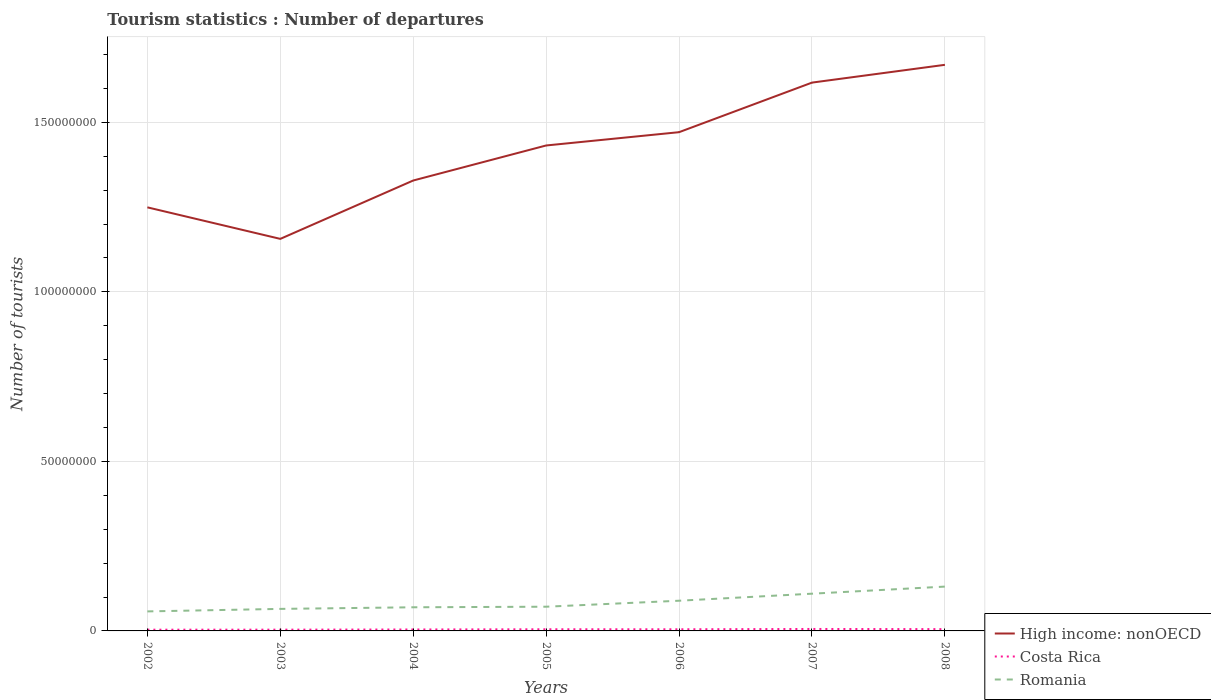How many different coloured lines are there?
Provide a short and direct response. 3. Is the number of lines equal to the number of legend labels?
Make the answer very short. Yes. Across all years, what is the maximum number of tourist departures in Romania?
Your answer should be very brief. 5.76e+06. In which year was the number of tourist departures in High income: nonOECD maximum?
Your answer should be very brief. 2003. What is the total number of tourist departures in Costa Rica in the graph?
Give a very brief answer. -1.52e+05. What is the difference between the highest and the second highest number of tourist departures in High income: nonOECD?
Give a very brief answer. 5.13e+07. What is the difference between the highest and the lowest number of tourist departures in Costa Rica?
Keep it short and to the point. 4. How many lines are there?
Your answer should be compact. 3. How many years are there in the graph?
Make the answer very short. 7. Does the graph contain any zero values?
Provide a succinct answer. No. Where does the legend appear in the graph?
Offer a terse response. Bottom right. How are the legend labels stacked?
Ensure brevity in your answer.  Vertical. What is the title of the graph?
Your response must be concise. Tourism statistics : Number of departures. What is the label or title of the Y-axis?
Your answer should be compact. Number of tourists. What is the Number of tourists of High income: nonOECD in 2002?
Your response must be concise. 1.25e+08. What is the Number of tourists of Costa Rica in 2002?
Give a very brief answer. 3.64e+05. What is the Number of tourists in Romania in 2002?
Make the answer very short. 5.76e+06. What is the Number of tourists of High income: nonOECD in 2003?
Provide a succinct answer. 1.16e+08. What is the Number of tourists in Costa Rica in 2003?
Your response must be concise. 3.73e+05. What is the Number of tourists in Romania in 2003?
Provide a short and direct response. 6.50e+06. What is the Number of tourists of High income: nonOECD in 2004?
Ensure brevity in your answer.  1.33e+08. What is the Number of tourists of Costa Rica in 2004?
Offer a terse response. 4.25e+05. What is the Number of tourists of Romania in 2004?
Provide a short and direct response. 6.97e+06. What is the Number of tourists in High income: nonOECD in 2005?
Make the answer very short. 1.43e+08. What is the Number of tourists in Costa Rica in 2005?
Offer a very short reply. 4.87e+05. What is the Number of tourists of Romania in 2005?
Offer a very short reply. 7.14e+06. What is the Number of tourists of High income: nonOECD in 2006?
Provide a succinct answer. 1.47e+08. What is the Number of tourists in Costa Rica in 2006?
Give a very brief answer. 4.85e+05. What is the Number of tourists of Romania in 2006?
Your answer should be compact. 8.91e+06. What is the Number of tourists of High income: nonOECD in 2007?
Provide a short and direct response. 1.62e+08. What is the Number of tourists in Costa Rica in 2007?
Make the answer very short. 5.77e+05. What is the Number of tourists of Romania in 2007?
Your answer should be compact. 1.10e+07. What is the Number of tourists of High income: nonOECD in 2008?
Offer a terse response. 1.67e+08. What is the Number of tourists in Costa Rica in 2008?
Your answer should be compact. 5.28e+05. What is the Number of tourists of Romania in 2008?
Ensure brevity in your answer.  1.31e+07. Across all years, what is the maximum Number of tourists of High income: nonOECD?
Your answer should be compact. 1.67e+08. Across all years, what is the maximum Number of tourists in Costa Rica?
Your answer should be compact. 5.77e+05. Across all years, what is the maximum Number of tourists in Romania?
Give a very brief answer. 1.31e+07. Across all years, what is the minimum Number of tourists of High income: nonOECD?
Provide a succinct answer. 1.16e+08. Across all years, what is the minimum Number of tourists in Costa Rica?
Ensure brevity in your answer.  3.64e+05. Across all years, what is the minimum Number of tourists of Romania?
Provide a short and direct response. 5.76e+06. What is the total Number of tourists of High income: nonOECD in the graph?
Give a very brief answer. 9.92e+08. What is the total Number of tourists of Costa Rica in the graph?
Your response must be concise. 3.24e+06. What is the total Number of tourists in Romania in the graph?
Your response must be concise. 5.93e+07. What is the difference between the Number of tourists in High income: nonOECD in 2002 and that in 2003?
Ensure brevity in your answer.  9.30e+06. What is the difference between the Number of tourists of Costa Rica in 2002 and that in 2003?
Keep it short and to the point. -9000. What is the difference between the Number of tourists in Romania in 2002 and that in 2003?
Provide a short and direct response. -7.40e+05. What is the difference between the Number of tourists of High income: nonOECD in 2002 and that in 2004?
Your answer should be compact. -7.91e+06. What is the difference between the Number of tourists in Costa Rica in 2002 and that in 2004?
Give a very brief answer. -6.10e+04. What is the difference between the Number of tourists in Romania in 2002 and that in 2004?
Your response must be concise. -1.22e+06. What is the difference between the Number of tourists in High income: nonOECD in 2002 and that in 2005?
Provide a succinct answer. -1.82e+07. What is the difference between the Number of tourists of Costa Rica in 2002 and that in 2005?
Provide a succinct answer. -1.23e+05. What is the difference between the Number of tourists of Romania in 2002 and that in 2005?
Your answer should be very brief. -1.38e+06. What is the difference between the Number of tourists of High income: nonOECD in 2002 and that in 2006?
Give a very brief answer. -2.22e+07. What is the difference between the Number of tourists of Costa Rica in 2002 and that in 2006?
Offer a very short reply. -1.21e+05. What is the difference between the Number of tourists in Romania in 2002 and that in 2006?
Provide a short and direct response. -3.15e+06. What is the difference between the Number of tourists of High income: nonOECD in 2002 and that in 2007?
Provide a short and direct response. -3.68e+07. What is the difference between the Number of tourists of Costa Rica in 2002 and that in 2007?
Your answer should be very brief. -2.13e+05. What is the difference between the Number of tourists of Romania in 2002 and that in 2007?
Offer a terse response. -5.22e+06. What is the difference between the Number of tourists in High income: nonOECD in 2002 and that in 2008?
Keep it short and to the point. -4.20e+07. What is the difference between the Number of tourists in Costa Rica in 2002 and that in 2008?
Provide a short and direct response. -1.64e+05. What is the difference between the Number of tourists in Romania in 2002 and that in 2008?
Offer a terse response. -7.32e+06. What is the difference between the Number of tourists of High income: nonOECD in 2003 and that in 2004?
Your response must be concise. -1.72e+07. What is the difference between the Number of tourists in Costa Rica in 2003 and that in 2004?
Offer a very short reply. -5.20e+04. What is the difference between the Number of tourists of Romania in 2003 and that in 2004?
Your answer should be compact. -4.75e+05. What is the difference between the Number of tourists of High income: nonOECD in 2003 and that in 2005?
Make the answer very short. -2.75e+07. What is the difference between the Number of tourists of Costa Rica in 2003 and that in 2005?
Make the answer very short. -1.14e+05. What is the difference between the Number of tourists of Romania in 2003 and that in 2005?
Give a very brief answer. -6.43e+05. What is the difference between the Number of tourists of High income: nonOECD in 2003 and that in 2006?
Your answer should be compact. -3.15e+07. What is the difference between the Number of tourists of Costa Rica in 2003 and that in 2006?
Give a very brief answer. -1.12e+05. What is the difference between the Number of tourists of Romania in 2003 and that in 2006?
Your response must be concise. -2.41e+06. What is the difference between the Number of tourists in High income: nonOECD in 2003 and that in 2007?
Ensure brevity in your answer.  -4.61e+07. What is the difference between the Number of tourists of Costa Rica in 2003 and that in 2007?
Make the answer very short. -2.04e+05. What is the difference between the Number of tourists of Romania in 2003 and that in 2007?
Offer a terse response. -4.48e+06. What is the difference between the Number of tourists in High income: nonOECD in 2003 and that in 2008?
Your response must be concise. -5.13e+07. What is the difference between the Number of tourists in Costa Rica in 2003 and that in 2008?
Ensure brevity in your answer.  -1.55e+05. What is the difference between the Number of tourists in Romania in 2003 and that in 2008?
Provide a succinct answer. -6.58e+06. What is the difference between the Number of tourists in High income: nonOECD in 2004 and that in 2005?
Ensure brevity in your answer.  -1.03e+07. What is the difference between the Number of tourists in Costa Rica in 2004 and that in 2005?
Provide a short and direct response. -6.20e+04. What is the difference between the Number of tourists of Romania in 2004 and that in 2005?
Ensure brevity in your answer.  -1.68e+05. What is the difference between the Number of tourists of High income: nonOECD in 2004 and that in 2006?
Offer a very short reply. -1.43e+07. What is the difference between the Number of tourists of Romania in 2004 and that in 2006?
Ensure brevity in your answer.  -1.93e+06. What is the difference between the Number of tourists of High income: nonOECD in 2004 and that in 2007?
Make the answer very short. -2.89e+07. What is the difference between the Number of tourists of Costa Rica in 2004 and that in 2007?
Provide a succinct answer. -1.52e+05. What is the difference between the Number of tourists in Romania in 2004 and that in 2007?
Give a very brief answer. -4.01e+06. What is the difference between the Number of tourists in High income: nonOECD in 2004 and that in 2008?
Ensure brevity in your answer.  -3.41e+07. What is the difference between the Number of tourists in Costa Rica in 2004 and that in 2008?
Your response must be concise. -1.03e+05. What is the difference between the Number of tourists in Romania in 2004 and that in 2008?
Provide a short and direct response. -6.10e+06. What is the difference between the Number of tourists in High income: nonOECD in 2005 and that in 2006?
Keep it short and to the point. -3.92e+06. What is the difference between the Number of tourists of Costa Rica in 2005 and that in 2006?
Offer a terse response. 2000. What is the difference between the Number of tourists in Romania in 2005 and that in 2006?
Keep it short and to the point. -1.77e+06. What is the difference between the Number of tourists of High income: nonOECD in 2005 and that in 2007?
Your response must be concise. -1.85e+07. What is the difference between the Number of tourists of Costa Rica in 2005 and that in 2007?
Your answer should be very brief. -9.00e+04. What is the difference between the Number of tourists in Romania in 2005 and that in 2007?
Your answer should be compact. -3.84e+06. What is the difference between the Number of tourists of High income: nonOECD in 2005 and that in 2008?
Make the answer very short. -2.38e+07. What is the difference between the Number of tourists of Costa Rica in 2005 and that in 2008?
Your answer should be compact. -4.10e+04. What is the difference between the Number of tourists of Romania in 2005 and that in 2008?
Make the answer very short. -5.93e+06. What is the difference between the Number of tourists in High income: nonOECD in 2006 and that in 2007?
Ensure brevity in your answer.  -1.46e+07. What is the difference between the Number of tourists of Costa Rica in 2006 and that in 2007?
Offer a terse response. -9.20e+04. What is the difference between the Number of tourists in Romania in 2006 and that in 2007?
Ensure brevity in your answer.  -2.07e+06. What is the difference between the Number of tourists of High income: nonOECD in 2006 and that in 2008?
Your answer should be compact. -1.99e+07. What is the difference between the Number of tourists of Costa Rica in 2006 and that in 2008?
Your answer should be compact. -4.30e+04. What is the difference between the Number of tourists of Romania in 2006 and that in 2008?
Offer a very short reply. -4.17e+06. What is the difference between the Number of tourists of High income: nonOECD in 2007 and that in 2008?
Your answer should be compact. -5.25e+06. What is the difference between the Number of tourists in Costa Rica in 2007 and that in 2008?
Give a very brief answer. 4.90e+04. What is the difference between the Number of tourists of Romania in 2007 and that in 2008?
Your response must be concise. -2.09e+06. What is the difference between the Number of tourists in High income: nonOECD in 2002 and the Number of tourists in Costa Rica in 2003?
Your answer should be compact. 1.25e+08. What is the difference between the Number of tourists of High income: nonOECD in 2002 and the Number of tourists of Romania in 2003?
Your answer should be compact. 1.18e+08. What is the difference between the Number of tourists of Costa Rica in 2002 and the Number of tourists of Romania in 2003?
Make the answer very short. -6.13e+06. What is the difference between the Number of tourists in High income: nonOECD in 2002 and the Number of tourists in Costa Rica in 2004?
Your response must be concise. 1.24e+08. What is the difference between the Number of tourists in High income: nonOECD in 2002 and the Number of tourists in Romania in 2004?
Give a very brief answer. 1.18e+08. What is the difference between the Number of tourists in Costa Rica in 2002 and the Number of tourists in Romania in 2004?
Your answer should be compact. -6.61e+06. What is the difference between the Number of tourists in High income: nonOECD in 2002 and the Number of tourists in Costa Rica in 2005?
Your response must be concise. 1.24e+08. What is the difference between the Number of tourists of High income: nonOECD in 2002 and the Number of tourists of Romania in 2005?
Make the answer very short. 1.18e+08. What is the difference between the Number of tourists of Costa Rica in 2002 and the Number of tourists of Romania in 2005?
Provide a succinct answer. -6.78e+06. What is the difference between the Number of tourists of High income: nonOECD in 2002 and the Number of tourists of Costa Rica in 2006?
Offer a terse response. 1.24e+08. What is the difference between the Number of tourists of High income: nonOECD in 2002 and the Number of tourists of Romania in 2006?
Make the answer very short. 1.16e+08. What is the difference between the Number of tourists of Costa Rica in 2002 and the Number of tourists of Romania in 2006?
Your response must be concise. -8.54e+06. What is the difference between the Number of tourists of High income: nonOECD in 2002 and the Number of tourists of Costa Rica in 2007?
Offer a very short reply. 1.24e+08. What is the difference between the Number of tourists of High income: nonOECD in 2002 and the Number of tourists of Romania in 2007?
Offer a terse response. 1.14e+08. What is the difference between the Number of tourists in Costa Rica in 2002 and the Number of tourists in Romania in 2007?
Offer a terse response. -1.06e+07. What is the difference between the Number of tourists of High income: nonOECD in 2002 and the Number of tourists of Costa Rica in 2008?
Provide a short and direct response. 1.24e+08. What is the difference between the Number of tourists in High income: nonOECD in 2002 and the Number of tourists in Romania in 2008?
Offer a very short reply. 1.12e+08. What is the difference between the Number of tourists of Costa Rica in 2002 and the Number of tourists of Romania in 2008?
Provide a succinct answer. -1.27e+07. What is the difference between the Number of tourists of High income: nonOECD in 2003 and the Number of tourists of Costa Rica in 2004?
Offer a very short reply. 1.15e+08. What is the difference between the Number of tourists of High income: nonOECD in 2003 and the Number of tourists of Romania in 2004?
Ensure brevity in your answer.  1.09e+08. What is the difference between the Number of tourists in Costa Rica in 2003 and the Number of tourists in Romania in 2004?
Provide a succinct answer. -6.60e+06. What is the difference between the Number of tourists in High income: nonOECD in 2003 and the Number of tourists in Costa Rica in 2005?
Offer a very short reply. 1.15e+08. What is the difference between the Number of tourists of High income: nonOECD in 2003 and the Number of tourists of Romania in 2005?
Provide a succinct answer. 1.08e+08. What is the difference between the Number of tourists of Costa Rica in 2003 and the Number of tourists of Romania in 2005?
Offer a very short reply. -6.77e+06. What is the difference between the Number of tourists in High income: nonOECD in 2003 and the Number of tourists in Costa Rica in 2006?
Provide a short and direct response. 1.15e+08. What is the difference between the Number of tourists in High income: nonOECD in 2003 and the Number of tourists in Romania in 2006?
Keep it short and to the point. 1.07e+08. What is the difference between the Number of tourists of Costa Rica in 2003 and the Number of tourists of Romania in 2006?
Make the answer very short. -8.53e+06. What is the difference between the Number of tourists in High income: nonOECD in 2003 and the Number of tourists in Costa Rica in 2007?
Give a very brief answer. 1.15e+08. What is the difference between the Number of tourists of High income: nonOECD in 2003 and the Number of tourists of Romania in 2007?
Your answer should be compact. 1.05e+08. What is the difference between the Number of tourists of Costa Rica in 2003 and the Number of tourists of Romania in 2007?
Your answer should be compact. -1.06e+07. What is the difference between the Number of tourists of High income: nonOECD in 2003 and the Number of tourists of Costa Rica in 2008?
Provide a short and direct response. 1.15e+08. What is the difference between the Number of tourists of High income: nonOECD in 2003 and the Number of tourists of Romania in 2008?
Your answer should be very brief. 1.03e+08. What is the difference between the Number of tourists of Costa Rica in 2003 and the Number of tourists of Romania in 2008?
Give a very brief answer. -1.27e+07. What is the difference between the Number of tourists of High income: nonOECD in 2004 and the Number of tourists of Costa Rica in 2005?
Your response must be concise. 1.32e+08. What is the difference between the Number of tourists of High income: nonOECD in 2004 and the Number of tourists of Romania in 2005?
Give a very brief answer. 1.26e+08. What is the difference between the Number of tourists of Costa Rica in 2004 and the Number of tourists of Romania in 2005?
Give a very brief answer. -6.72e+06. What is the difference between the Number of tourists in High income: nonOECD in 2004 and the Number of tourists in Costa Rica in 2006?
Give a very brief answer. 1.32e+08. What is the difference between the Number of tourists in High income: nonOECD in 2004 and the Number of tourists in Romania in 2006?
Your answer should be very brief. 1.24e+08. What is the difference between the Number of tourists of Costa Rica in 2004 and the Number of tourists of Romania in 2006?
Offer a very short reply. -8.48e+06. What is the difference between the Number of tourists in High income: nonOECD in 2004 and the Number of tourists in Costa Rica in 2007?
Ensure brevity in your answer.  1.32e+08. What is the difference between the Number of tourists of High income: nonOECD in 2004 and the Number of tourists of Romania in 2007?
Ensure brevity in your answer.  1.22e+08. What is the difference between the Number of tourists in Costa Rica in 2004 and the Number of tourists in Romania in 2007?
Make the answer very short. -1.06e+07. What is the difference between the Number of tourists of High income: nonOECD in 2004 and the Number of tourists of Costa Rica in 2008?
Your response must be concise. 1.32e+08. What is the difference between the Number of tourists of High income: nonOECD in 2004 and the Number of tourists of Romania in 2008?
Offer a very short reply. 1.20e+08. What is the difference between the Number of tourists in Costa Rica in 2004 and the Number of tourists in Romania in 2008?
Provide a short and direct response. -1.26e+07. What is the difference between the Number of tourists in High income: nonOECD in 2005 and the Number of tourists in Costa Rica in 2006?
Ensure brevity in your answer.  1.43e+08. What is the difference between the Number of tourists of High income: nonOECD in 2005 and the Number of tourists of Romania in 2006?
Give a very brief answer. 1.34e+08. What is the difference between the Number of tourists in Costa Rica in 2005 and the Number of tourists in Romania in 2006?
Offer a terse response. -8.42e+06. What is the difference between the Number of tourists of High income: nonOECD in 2005 and the Number of tourists of Costa Rica in 2007?
Your answer should be compact. 1.43e+08. What is the difference between the Number of tourists in High income: nonOECD in 2005 and the Number of tourists in Romania in 2007?
Give a very brief answer. 1.32e+08. What is the difference between the Number of tourists of Costa Rica in 2005 and the Number of tourists of Romania in 2007?
Your answer should be very brief. -1.05e+07. What is the difference between the Number of tourists of High income: nonOECD in 2005 and the Number of tourists of Costa Rica in 2008?
Keep it short and to the point. 1.43e+08. What is the difference between the Number of tourists in High income: nonOECD in 2005 and the Number of tourists in Romania in 2008?
Provide a succinct answer. 1.30e+08. What is the difference between the Number of tourists of Costa Rica in 2005 and the Number of tourists of Romania in 2008?
Offer a very short reply. -1.26e+07. What is the difference between the Number of tourists of High income: nonOECD in 2006 and the Number of tourists of Costa Rica in 2007?
Offer a terse response. 1.47e+08. What is the difference between the Number of tourists of High income: nonOECD in 2006 and the Number of tourists of Romania in 2007?
Give a very brief answer. 1.36e+08. What is the difference between the Number of tourists in Costa Rica in 2006 and the Number of tourists in Romania in 2007?
Your answer should be very brief. -1.05e+07. What is the difference between the Number of tourists of High income: nonOECD in 2006 and the Number of tourists of Costa Rica in 2008?
Make the answer very short. 1.47e+08. What is the difference between the Number of tourists of High income: nonOECD in 2006 and the Number of tourists of Romania in 2008?
Provide a short and direct response. 1.34e+08. What is the difference between the Number of tourists of Costa Rica in 2006 and the Number of tourists of Romania in 2008?
Offer a terse response. -1.26e+07. What is the difference between the Number of tourists in High income: nonOECD in 2007 and the Number of tourists in Costa Rica in 2008?
Offer a very short reply. 1.61e+08. What is the difference between the Number of tourists in High income: nonOECD in 2007 and the Number of tourists in Romania in 2008?
Your answer should be very brief. 1.49e+08. What is the difference between the Number of tourists in Costa Rica in 2007 and the Number of tourists in Romania in 2008?
Make the answer very short. -1.25e+07. What is the average Number of tourists in High income: nonOECD per year?
Provide a short and direct response. 1.42e+08. What is the average Number of tourists in Costa Rica per year?
Provide a short and direct response. 4.63e+05. What is the average Number of tourists of Romania per year?
Give a very brief answer. 8.47e+06. In the year 2002, what is the difference between the Number of tourists in High income: nonOECD and Number of tourists in Costa Rica?
Your answer should be compact. 1.25e+08. In the year 2002, what is the difference between the Number of tourists in High income: nonOECD and Number of tourists in Romania?
Your answer should be compact. 1.19e+08. In the year 2002, what is the difference between the Number of tourists in Costa Rica and Number of tourists in Romania?
Keep it short and to the point. -5.39e+06. In the year 2003, what is the difference between the Number of tourists of High income: nonOECD and Number of tourists of Costa Rica?
Provide a succinct answer. 1.15e+08. In the year 2003, what is the difference between the Number of tourists of High income: nonOECD and Number of tourists of Romania?
Offer a terse response. 1.09e+08. In the year 2003, what is the difference between the Number of tourists of Costa Rica and Number of tourists of Romania?
Offer a very short reply. -6.12e+06. In the year 2004, what is the difference between the Number of tourists in High income: nonOECD and Number of tourists in Costa Rica?
Ensure brevity in your answer.  1.32e+08. In the year 2004, what is the difference between the Number of tourists in High income: nonOECD and Number of tourists in Romania?
Make the answer very short. 1.26e+08. In the year 2004, what is the difference between the Number of tourists of Costa Rica and Number of tourists of Romania?
Your answer should be very brief. -6.55e+06. In the year 2005, what is the difference between the Number of tourists in High income: nonOECD and Number of tourists in Costa Rica?
Make the answer very short. 1.43e+08. In the year 2005, what is the difference between the Number of tourists in High income: nonOECD and Number of tourists in Romania?
Make the answer very short. 1.36e+08. In the year 2005, what is the difference between the Number of tourists of Costa Rica and Number of tourists of Romania?
Offer a very short reply. -6.65e+06. In the year 2006, what is the difference between the Number of tourists of High income: nonOECD and Number of tourists of Costa Rica?
Make the answer very short. 1.47e+08. In the year 2006, what is the difference between the Number of tourists in High income: nonOECD and Number of tourists in Romania?
Offer a terse response. 1.38e+08. In the year 2006, what is the difference between the Number of tourists in Costa Rica and Number of tourists in Romania?
Give a very brief answer. -8.42e+06. In the year 2007, what is the difference between the Number of tourists of High income: nonOECD and Number of tourists of Costa Rica?
Offer a terse response. 1.61e+08. In the year 2007, what is the difference between the Number of tourists of High income: nonOECD and Number of tourists of Romania?
Provide a succinct answer. 1.51e+08. In the year 2007, what is the difference between the Number of tourists in Costa Rica and Number of tourists in Romania?
Provide a succinct answer. -1.04e+07. In the year 2008, what is the difference between the Number of tourists in High income: nonOECD and Number of tourists in Costa Rica?
Provide a succinct answer. 1.66e+08. In the year 2008, what is the difference between the Number of tourists of High income: nonOECD and Number of tourists of Romania?
Keep it short and to the point. 1.54e+08. In the year 2008, what is the difference between the Number of tourists of Costa Rica and Number of tourists of Romania?
Provide a succinct answer. -1.25e+07. What is the ratio of the Number of tourists in High income: nonOECD in 2002 to that in 2003?
Give a very brief answer. 1.08. What is the ratio of the Number of tourists in Costa Rica in 2002 to that in 2003?
Your response must be concise. 0.98. What is the ratio of the Number of tourists of Romania in 2002 to that in 2003?
Your response must be concise. 0.89. What is the ratio of the Number of tourists of High income: nonOECD in 2002 to that in 2004?
Make the answer very short. 0.94. What is the ratio of the Number of tourists of Costa Rica in 2002 to that in 2004?
Your response must be concise. 0.86. What is the ratio of the Number of tourists of Romania in 2002 to that in 2004?
Make the answer very short. 0.83. What is the ratio of the Number of tourists in High income: nonOECD in 2002 to that in 2005?
Offer a terse response. 0.87. What is the ratio of the Number of tourists of Costa Rica in 2002 to that in 2005?
Give a very brief answer. 0.75. What is the ratio of the Number of tourists of Romania in 2002 to that in 2005?
Offer a terse response. 0.81. What is the ratio of the Number of tourists in High income: nonOECD in 2002 to that in 2006?
Provide a succinct answer. 0.85. What is the ratio of the Number of tourists in Costa Rica in 2002 to that in 2006?
Your answer should be very brief. 0.75. What is the ratio of the Number of tourists of Romania in 2002 to that in 2006?
Provide a short and direct response. 0.65. What is the ratio of the Number of tourists in High income: nonOECD in 2002 to that in 2007?
Offer a very short reply. 0.77. What is the ratio of the Number of tourists of Costa Rica in 2002 to that in 2007?
Offer a very short reply. 0.63. What is the ratio of the Number of tourists in Romania in 2002 to that in 2007?
Your response must be concise. 0.52. What is the ratio of the Number of tourists of High income: nonOECD in 2002 to that in 2008?
Provide a succinct answer. 0.75. What is the ratio of the Number of tourists in Costa Rica in 2002 to that in 2008?
Offer a very short reply. 0.69. What is the ratio of the Number of tourists in Romania in 2002 to that in 2008?
Ensure brevity in your answer.  0.44. What is the ratio of the Number of tourists of High income: nonOECD in 2003 to that in 2004?
Your answer should be compact. 0.87. What is the ratio of the Number of tourists of Costa Rica in 2003 to that in 2004?
Your answer should be compact. 0.88. What is the ratio of the Number of tourists in Romania in 2003 to that in 2004?
Offer a terse response. 0.93. What is the ratio of the Number of tourists of High income: nonOECD in 2003 to that in 2005?
Offer a terse response. 0.81. What is the ratio of the Number of tourists of Costa Rica in 2003 to that in 2005?
Offer a very short reply. 0.77. What is the ratio of the Number of tourists in Romania in 2003 to that in 2005?
Provide a succinct answer. 0.91. What is the ratio of the Number of tourists of High income: nonOECD in 2003 to that in 2006?
Give a very brief answer. 0.79. What is the ratio of the Number of tourists of Costa Rica in 2003 to that in 2006?
Your answer should be very brief. 0.77. What is the ratio of the Number of tourists of Romania in 2003 to that in 2006?
Give a very brief answer. 0.73. What is the ratio of the Number of tourists in High income: nonOECD in 2003 to that in 2007?
Provide a short and direct response. 0.71. What is the ratio of the Number of tourists of Costa Rica in 2003 to that in 2007?
Your answer should be compact. 0.65. What is the ratio of the Number of tourists in Romania in 2003 to that in 2007?
Your answer should be compact. 0.59. What is the ratio of the Number of tourists of High income: nonOECD in 2003 to that in 2008?
Offer a very short reply. 0.69. What is the ratio of the Number of tourists in Costa Rica in 2003 to that in 2008?
Your answer should be very brief. 0.71. What is the ratio of the Number of tourists in Romania in 2003 to that in 2008?
Your answer should be very brief. 0.5. What is the ratio of the Number of tourists of High income: nonOECD in 2004 to that in 2005?
Keep it short and to the point. 0.93. What is the ratio of the Number of tourists in Costa Rica in 2004 to that in 2005?
Provide a short and direct response. 0.87. What is the ratio of the Number of tourists in Romania in 2004 to that in 2005?
Keep it short and to the point. 0.98. What is the ratio of the Number of tourists in High income: nonOECD in 2004 to that in 2006?
Your answer should be very brief. 0.9. What is the ratio of the Number of tourists in Costa Rica in 2004 to that in 2006?
Offer a terse response. 0.88. What is the ratio of the Number of tourists in Romania in 2004 to that in 2006?
Your response must be concise. 0.78. What is the ratio of the Number of tourists in High income: nonOECD in 2004 to that in 2007?
Your response must be concise. 0.82. What is the ratio of the Number of tourists of Costa Rica in 2004 to that in 2007?
Offer a terse response. 0.74. What is the ratio of the Number of tourists of Romania in 2004 to that in 2007?
Offer a terse response. 0.64. What is the ratio of the Number of tourists in High income: nonOECD in 2004 to that in 2008?
Ensure brevity in your answer.  0.8. What is the ratio of the Number of tourists in Costa Rica in 2004 to that in 2008?
Ensure brevity in your answer.  0.8. What is the ratio of the Number of tourists of Romania in 2004 to that in 2008?
Make the answer very short. 0.53. What is the ratio of the Number of tourists of High income: nonOECD in 2005 to that in 2006?
Make the answer very short. 0.97. What is the ratio of the Number of tourists in Costa Rica in 2005 to that in 2006?
Offer a terse response. 1. What is the ratio of the Number of tourists of Romania in 2005 to that in 2006?
Keep it short and to the point. 0.8. What is the ratio of the Number of tourists in High income: nonOECD in 2005 to that in 2007?
Provide a short and direct response. 0.89. What is the ratio of the Number of tourists in Costa Rica in 2005 to that in 2007?
Offer a very short reply. 0.84. What is the ratio of the Number of tourists in Romania in 2005 to that in 2007?
Make the answer very short. 0.65. What is the ratio of the Number of tourists in High income: nonOECD in 2005 to that in 2008?
Offer a very short reply. 0.86. What is the ratio of the Number of tourists in Costa Rica in 2005 to that in 2008?
Provide a succinct answer. 0.92. What is the ratio of the Number of tourists of Romania in 2005 to that in 2008?
Offer a terse response. 0.55. What is the ratio of the Number of tourists of High income: nonOECD in 2006 to that in 2007?
Make the answer very short. 0.91. What is the ratio of the Number of tourists of Costa Rica in 2006 to that in 2007?
Your response must be concise. 0.84. What is the ratio of the Number of tourists in Romania in 2006 to that in 2007?
Ensure brevity in your answer.  0.81. What is the ratio of the Number of tourists of High income: nonOECD in 2006 to that in 2008?
Ensure brevity in your answer.  0.88. What is the ratio of the Number of tourists in Costa Rica in 2006 to that in 2008?
Provide a short and direct response. 0.92. What is the ratio of the Number of tourists in Romania in 2006 to that in 2008?
Your answer should be very brief. 0.68. What is the ratio of the Number of tourists of High income: nonOECD in 2007 to that in 2008?
Ensure brevity in your answer.  0.97. What is the ratio of the Number of tourists of Costa Rica in 2007 to that in 2008?
Provide a succinct answer. 1.09. What is the ratio of the Number of tourists of Romania in 2007 to that in 2008?
Make the answer very short. 0.84. What is the difference between the highest and the second highest Number of tourists in High income: nonOECD?
Your answer should be compact. 5.25e+06. What is the difference between the highest and the second highest Number of tourists of Costa Rica?
Give a very brief answer. 4.90e+04. What is the difference between the highest and the second highest Number of tourists of Romania?
Ensure brevity in your answer.  2.09e+06. What is the difference between the highest and the lowest Number of tourists of High income: nonOECD?
Your answer should be compact. 5.13e+07. What is the difference between the highest and the lowest Number of tourists in Costa Rica?
Give a very brief answer. 2.13e+05. What is the difference between the highest and the lowest Number of tourists of Romania?
Offer a very short reply. 7.32e+06. 